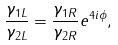<formula> <loc_0><loc_0><loc_500><loc_500>\frac { \gamma _ { 1 L } } { \gamma _ { 2 L } } = \frac { \gamma _ { 1 R } } { \gamma _ { 2 R } } e ^ { 4 i \phi } ,</formula> 